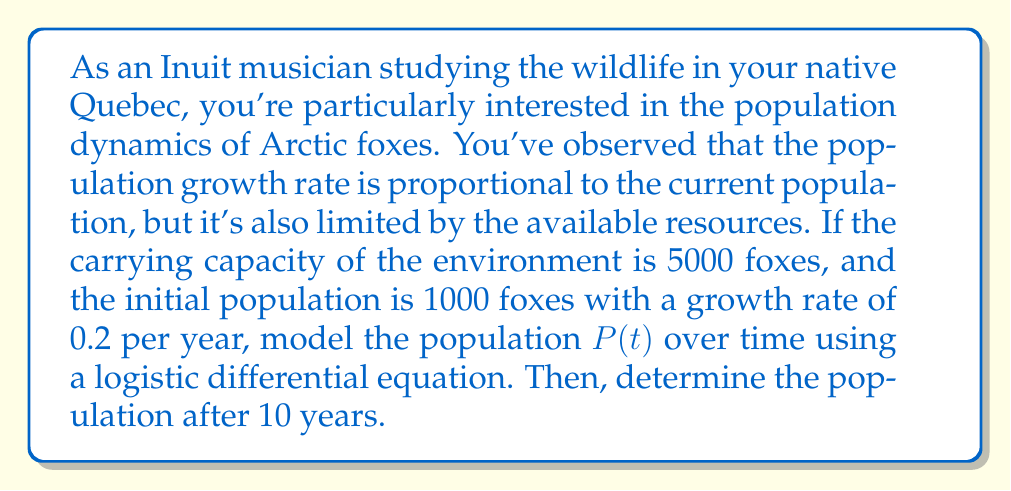Can you solve this math problem? To model this population, we'll use the logistic growth differential equation:

$$\frac{dP}{dt} = rP(1 - \frac{P}{K})$$

Where:
$P$ is the population
$t$ is time in years
$r$ is the growth rate (0.2 per year)
$K$ is the carrying capacity (5000 foxes)

1) First, we set up the differential equation with our given values:

   $$\frac{dP}{dt} = 0.2P(1 - \frac{P}{5000})$$

2) This is a separable differential equation. To solve it, we separate variables:

   $$\int \frac{dP}{P(1 - \frac{P}{5000})} = \int 0.2 dt$$

3) The left side can be solved using partial fractions:

   $$\int (\frac{1}{P} + \frac{1}{5000 - P}) dP = 0.2t + C$$

4) Integrating both sides:

   $$\ln|P| - \ln|5000 - P| = 0.2t + C$$

5) Simplifying and applying the exponential function to both sides:

   $$\frac{P}{5000 - P} = Ae^{0.2t}$$

   Where $A = e^C$

6) Solving for $P$:

   $$P = \frac{5000Ae^{0.2t}}{1 + Ae^{0.2t}}$$

7) To find $A$, we use the initial condition $P(0) = 1000$:

   $$1000 = \frac{5000A}{1 + A}$$

   Solving this, we get $A = \frac{1}{4}$

8) Our final solution is:

   $$P(t) = \frac{5000(\frac{1}{4})e^{0.2t}}{1 + (\frac{1}{4})e^{0.2t}} = \frac{1250e^{0.2t}}{1 + 0.25e^{0.2t}}$$

9) To find the population after 10 years, we substitute $t = 10$:

   $$P(10) = \frac{1250e^2}{1 + 0.25e^2} \approx 3385.61$$
Answer: The population of Arctic foxes after 10 years will be approximately 3386 foxes. 